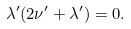<formula> <loc_0><loc_0><loc_500><loc_500>\lambda ^ { \prime } ( 2 \nu ^ { \prime } + \lambda ^ { \prime } ) = 0 .</formula> 